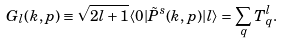<formula> <loc_0><loc_0><loc_500><loc_500>G _ { l } ( k , p ) \equiv \sqrt { 2 l + 1 } \langle 0 | \tilde { P } ^ { s } ( k , p ) | l \rangle = \sum _ { q } T _ { q } ^ { l } .</formula> 